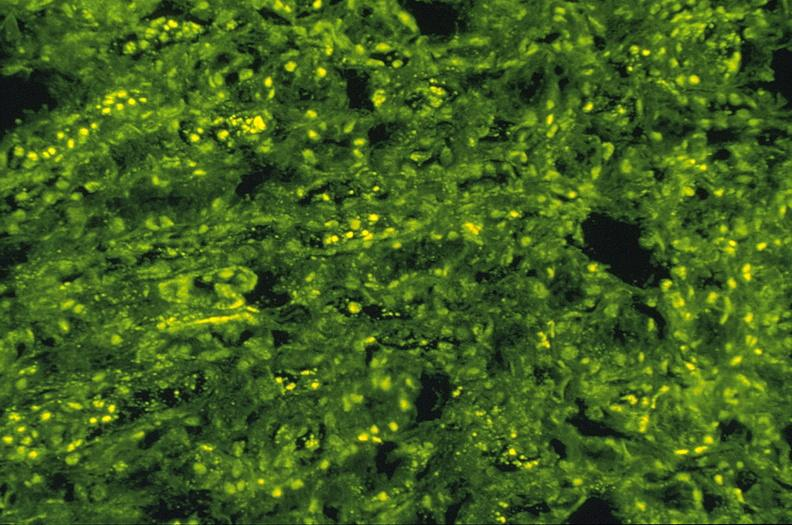s urinary present?
Answer the question using a single word or phrase. Yes 